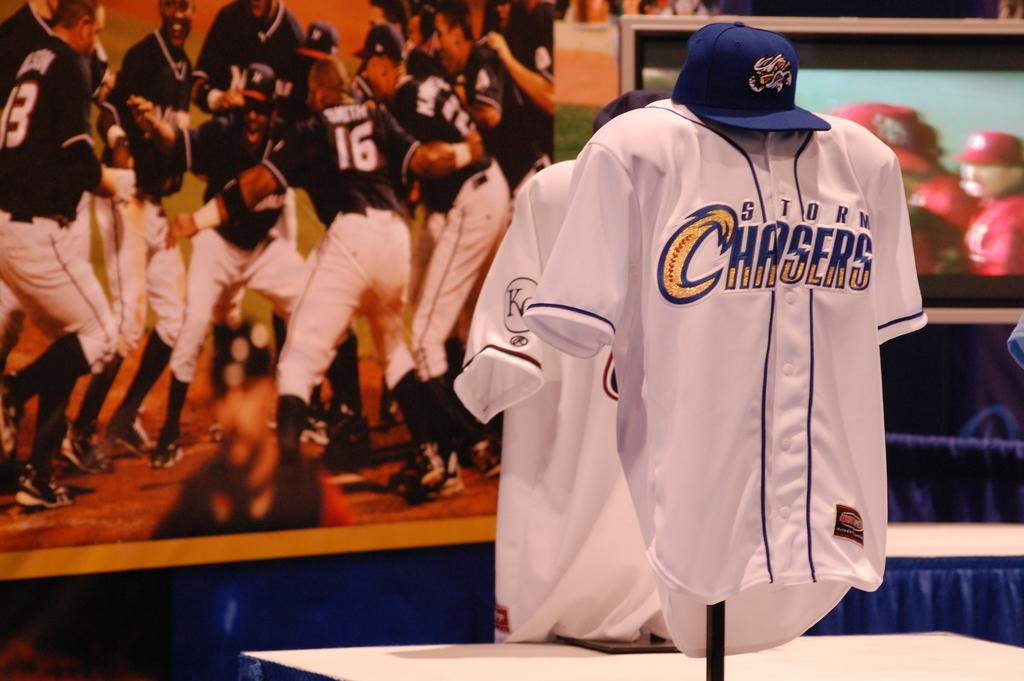What is the main piece of furniture in the image? There is a table in the image. What items are placed on the table? There are two shirts and caps on the table. What can be seen in the background of the image? There is a poster in the background. What is depicted on the poster? The poster features players. How many sticks are used to create the quilt on the table? There is no quilt or sticks present on the table in the image. Can you describe the feet of the players on the poster? There is no reference to the feet of the players on the poster in the image. 